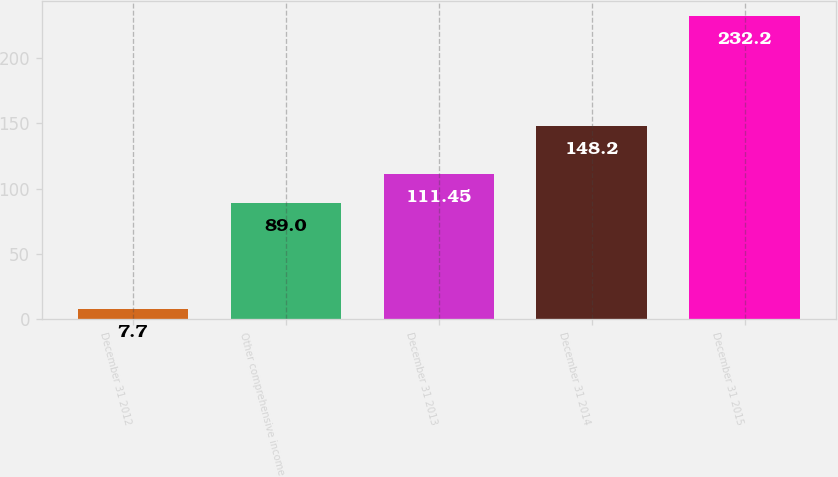Convert chart. <chart><loc_0><loc_0><loc_500><loc_500><bar_chart><fcel>December 31 2012<fcel>Other comprehensive income<fcel>December 31 2013<fcel>December 31 2014<fcel>December 31 2015<nl><fcel>7.7<fcel>89<fcel>111.45<fcel>148.2<fcel>232.2<nl></chart> 